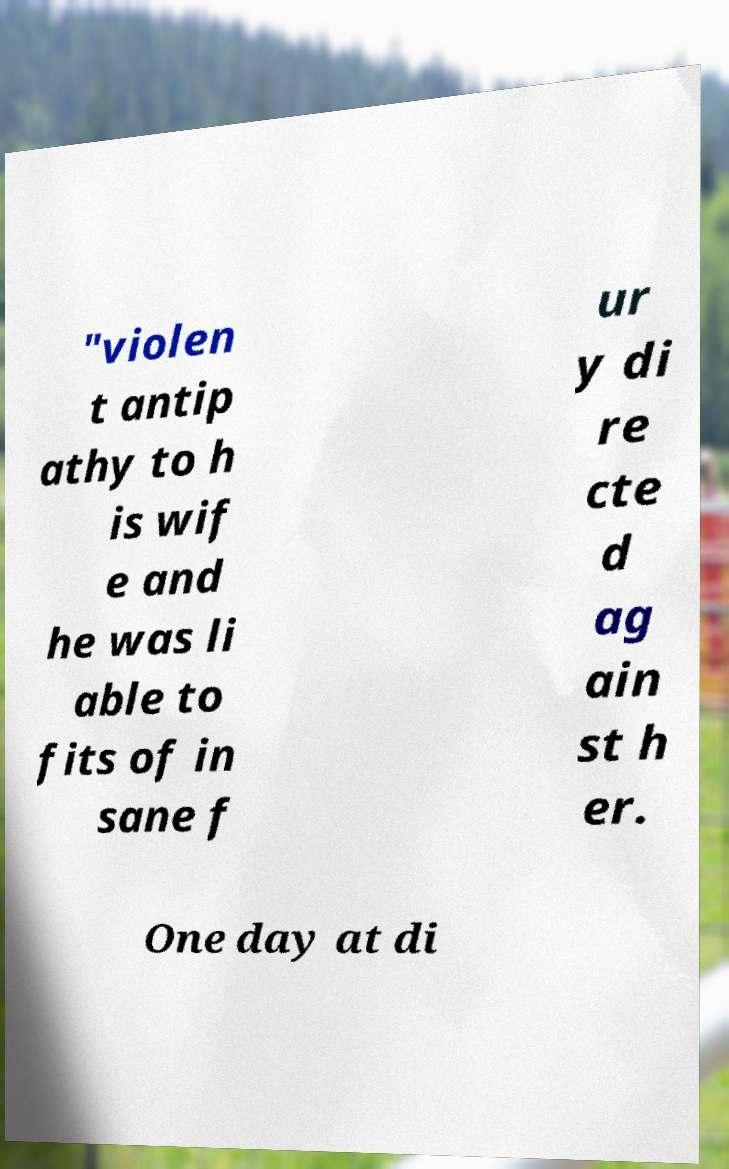Please identify and transcribe the text found in this image. "violen t antip athy to h is wif e and he was li able to fits of in sane f ur y di re cte d ag ain st h er. One day at di 